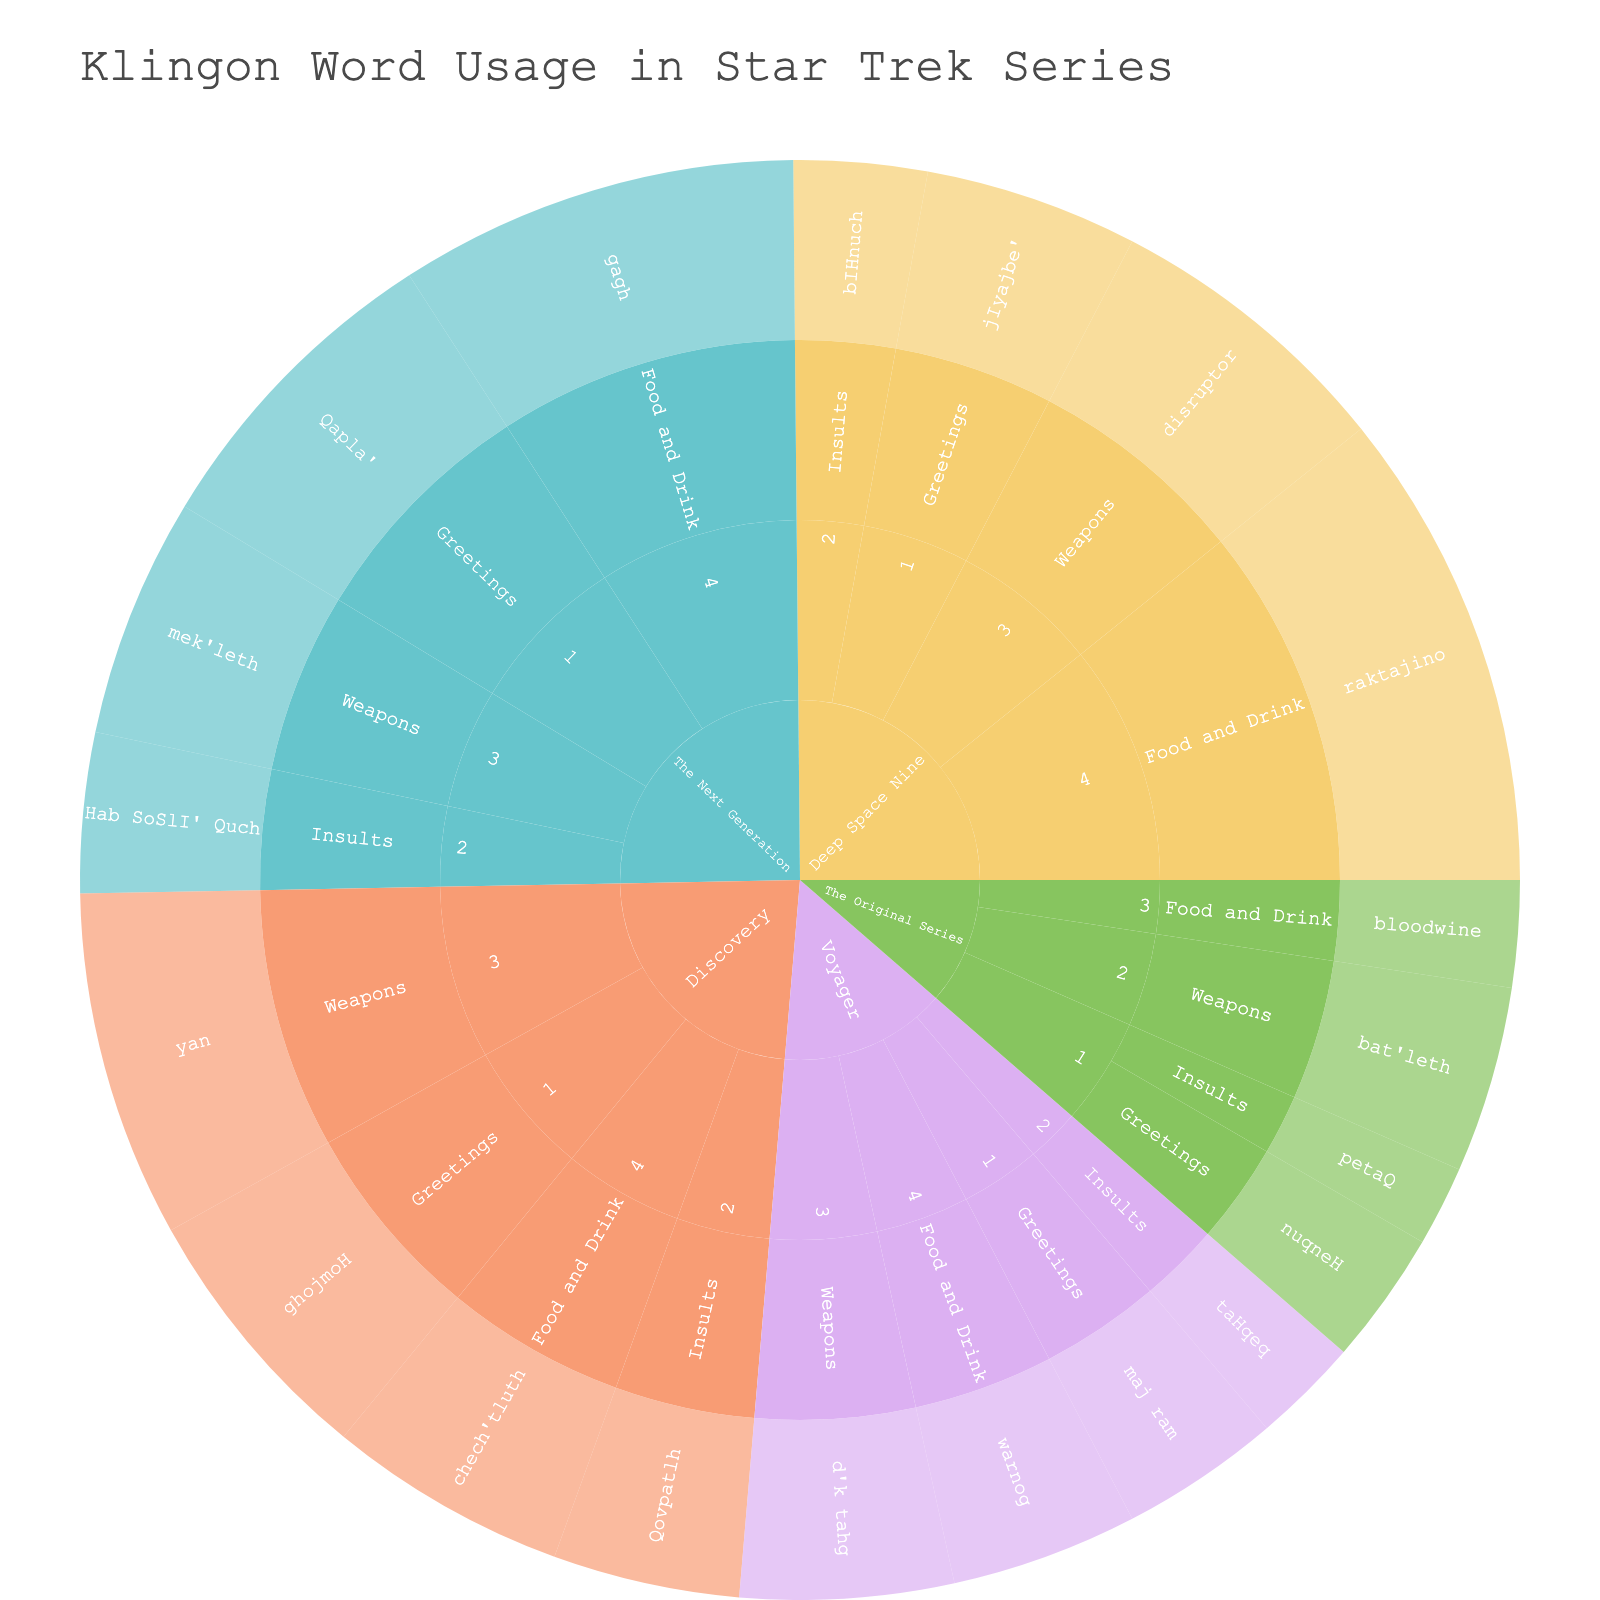What is the sunburst plot's title? It's displayed at the top of the plot. It's usually larger and bolder than other text.
Answer: Klingon Word Usage in Star Trek Series Which series has the highest usage of Klingon words? By examining the outermost segments, Discovery has the largest segments, indicating the highest counts.
Answer: Discovery Which word category has the most usage in "The Next Generation" season 4? By following the hierarchy: The Next Generation > Season 4 > Word Category, we see that Food and Drink has the largest segment.
Answer: Food and Drink What is the total usage count of Klingon greetings in "The Original Series"? Summing the usage counts of the greetings in The Original Series across seasons: season 1 nuqneH = 5.
Answer: 5 Compare the usage of Klingon insults between "Deep Space Nine" season 2 and "Voyager" season 2. By looking at the respective segments for Deep Space Nine season 2 (Insults: bIHnuch = 5) and Voyager season 2 (Insults: taHqeq = 4), we see bIHnuch has a higher count.
Answer: Deep Space Nine Which series used the word "gagh" and in which season? By navigating the sunburst, gagh is under The Next Generation, season 4.
Answer: The Next Generation, season 4 What is the combined usage count of "bat'leth" and "mek'leth"? Summing the usage counts found under The Original Series season 2 (bat'leth = 7) and The Next Generation season 3 (mek'leth = 9).
Answer: 16 Identify the series and season where "chech'tluth" was used. By following the segment with the word "chech'tluth," it's under Discovery season 4.
Answer: Discovery, season 4 How does the usage of "raktajino" compare to "warnog"? Look at their respective segments: "raktajino" (Deep Space Nine, season 4, with 18) and "warnog" (Voyager, season 4, with 7). Raktajino has a higher usage.
Answer: raktajino > warnog 